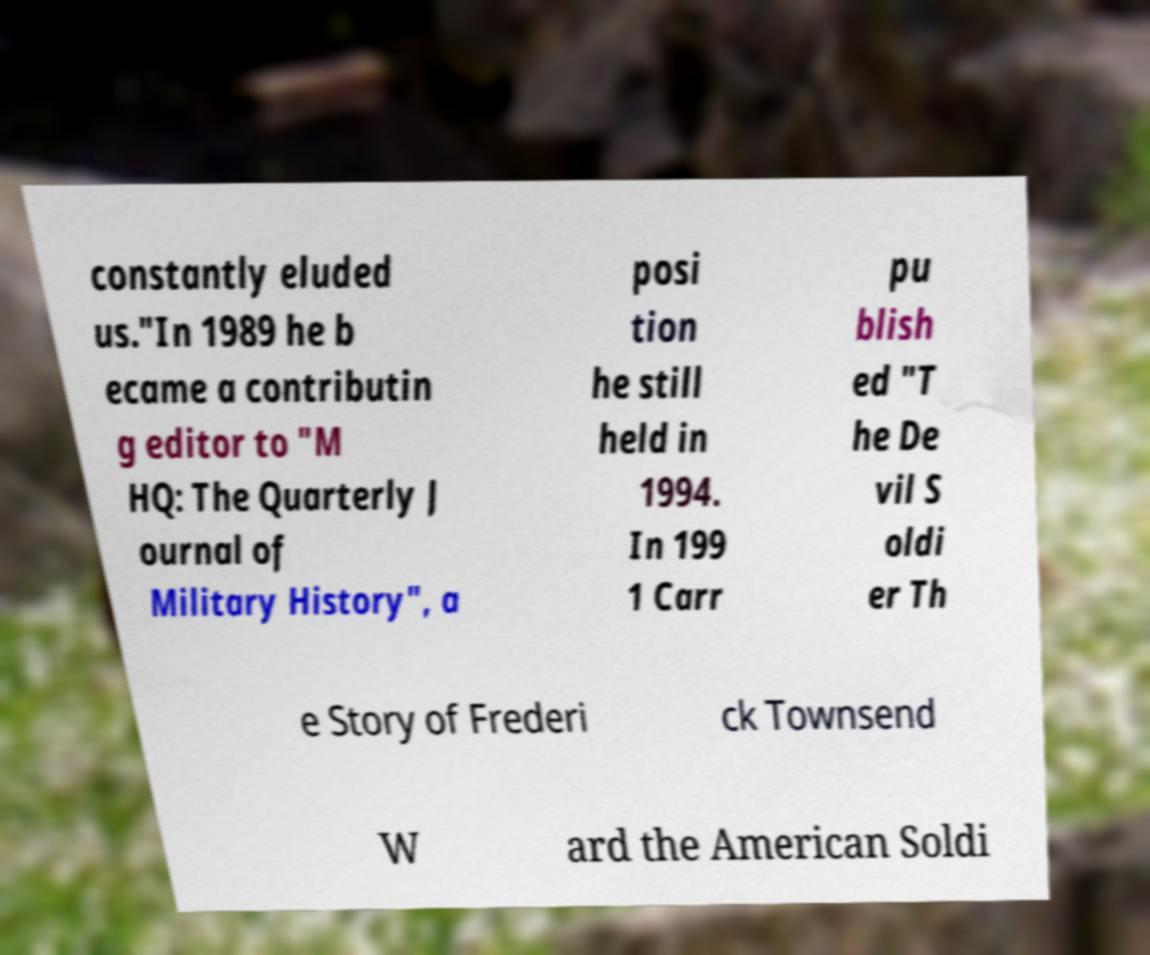What messages or text are displayed in this image? I need them in a readable, typed format. constantly eluded us."In 1989 he b ecame a contributin g editor to "M HQ: The Quarterly J ournal of Military History", a posi tion he still held in 1994. In 199 1 Carr pu blish ed "T he De vil S oldi er Th e Story of Frederi ck Townsend W ard the American Soldi 